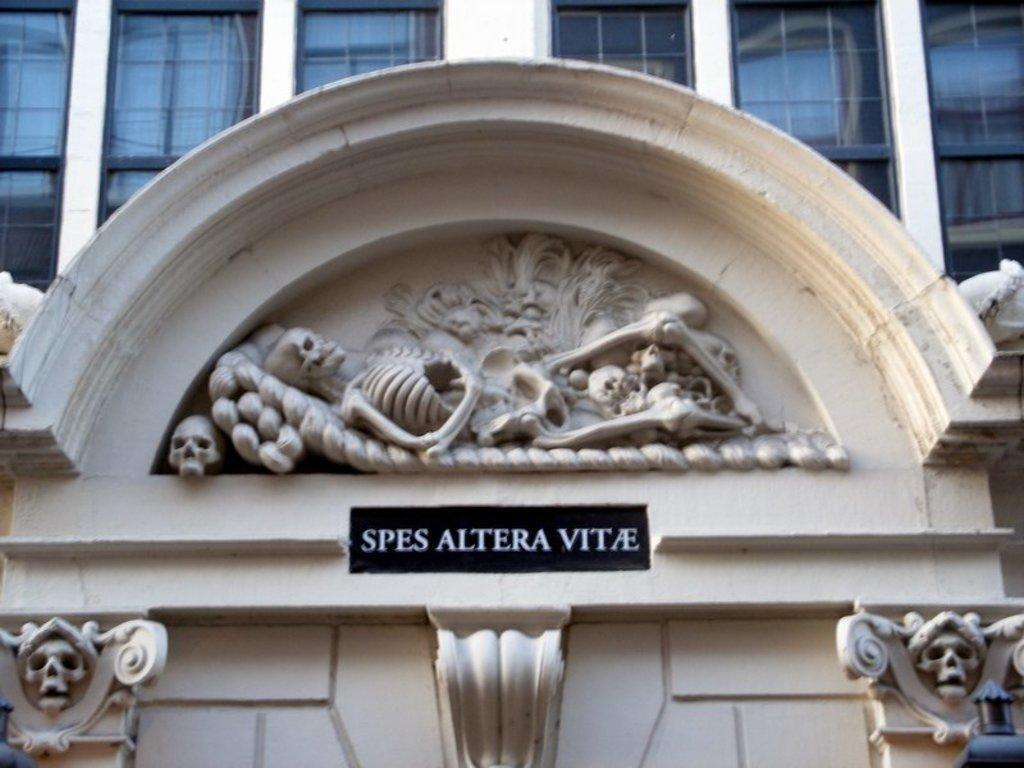How would you summarize this image in a sentence or two? This image consists of a building in white color. In the front, we can see a board and an art in shape of skeleton. At the top, there are windows. 